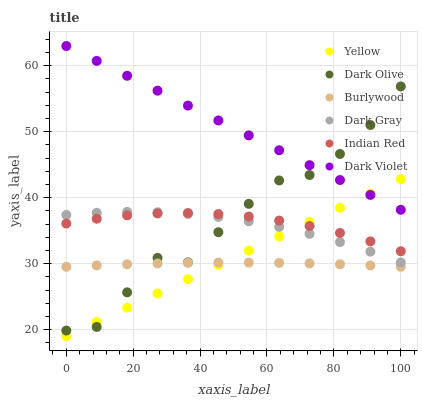Does Burlywood have the minimum area under the curve?
Answer yes or no. Yes. Does Dark Violet have the maximum area under the curve?
Answer yes or no. Yes. Does Dark Olive have the minimum area under the curve?
Answer yes or no. No. Does Dark Olive have the maximum area under the curve?
Answer yes or no. No. Is Yellow the smoothest?
Answer yes or no. Yes. Is Dark Olive the roughest?
Answer yes or no. Yes. Is Dark Violet the smoothest?
Answer yes or no. No. Is Dark Violet the roughest?
Answer yes or no. No. Does Yellow have the lowest value?
Answer yes or no. Yes. Does Dark Olive have the lowest value?
Answer yes or no. No. Does Dark Violet have the highest value?
Answer yes or no. Yes. Does Dark Olive have the highest value?
Answer yes or no. No. Is Indian Red less than Dark Violet?
Answer yes or no. Yes. Is Indian Red greater than Burlywood?
Answer yes or no. Yes. Does Indian Red intersect Dark Olive?
Answer yes or no. Yes. Is Indian Red less than Dark Olive?
Answer yes or no. No. Is Indian Red greater than Dark Olive?
Answer yes or no. No. Does Indian Red intersect Dark Violet?
Answer yes or no. No. 